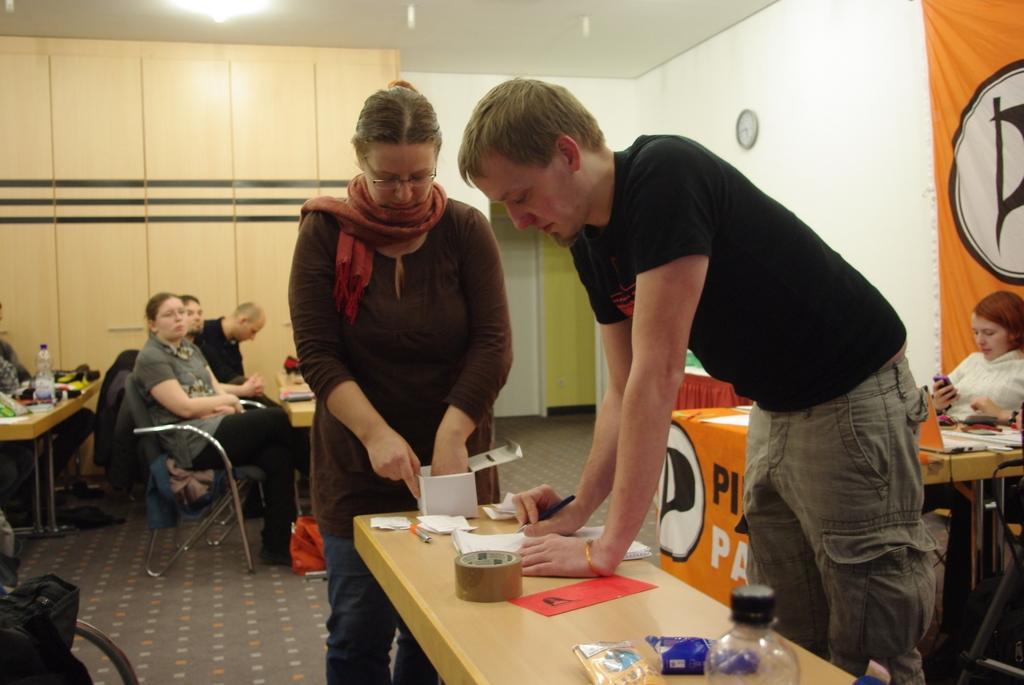Could you give a brief overview of what you see in this image? In this image we can see this persons are standing near the table. There are few papers, tape, box and bottle on the table. In the background we can see this people are sitting on the chairs near the table. These are the cupboards, banners and wall clock. 